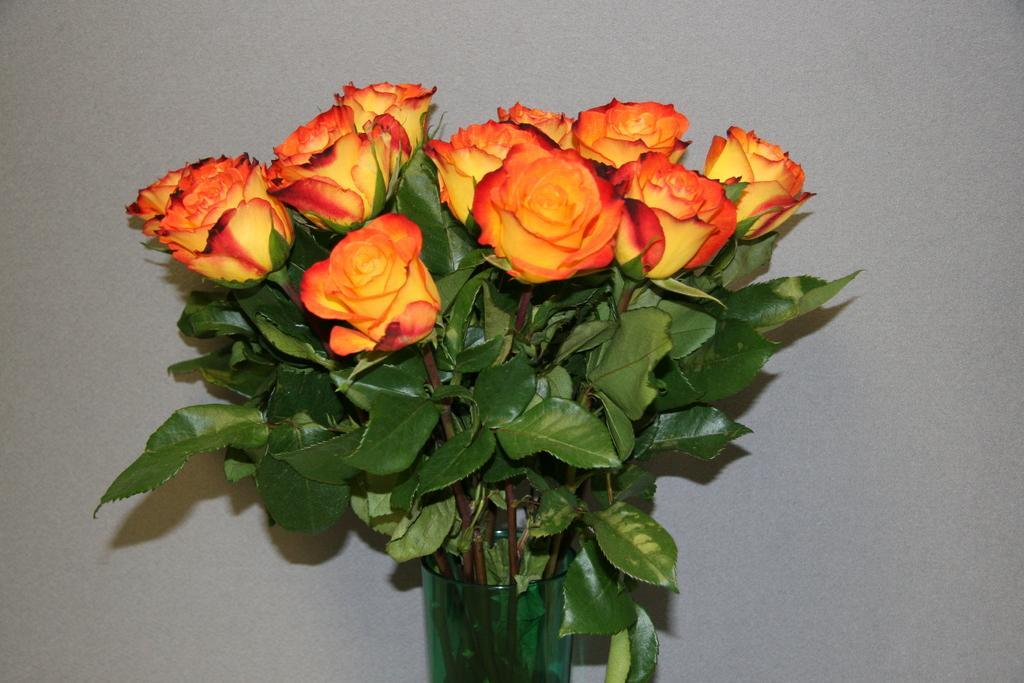How would you summarize this image in a sentence or two? In the center of this picture we can see the flower vase containing flowers and the green leaves. In the background there is an object which seems to be the wall. 